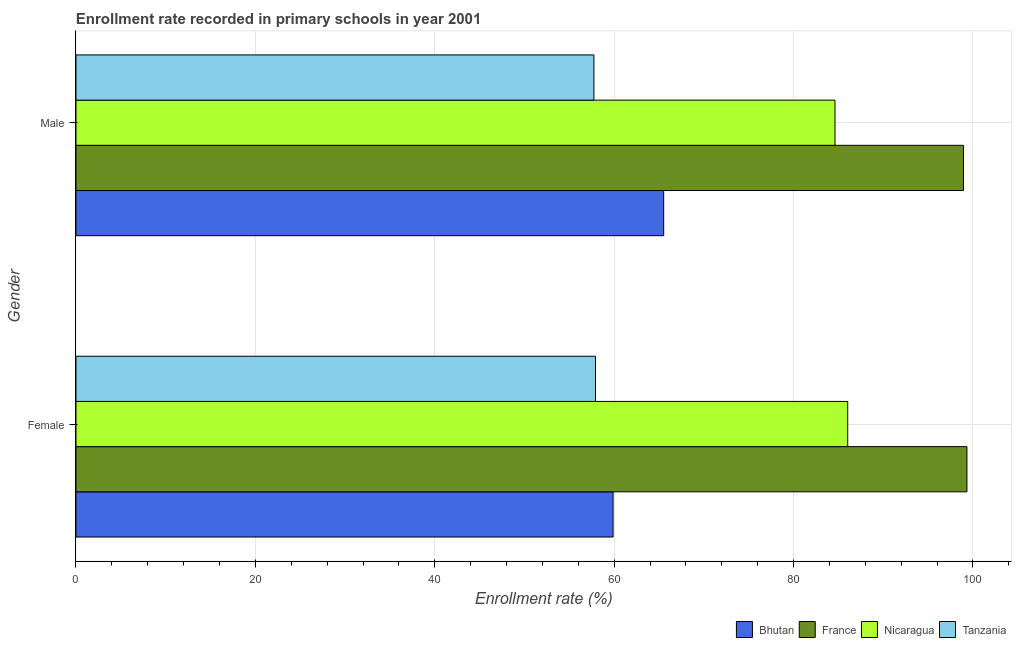How many different coloured bars are there?
Make the answer very short. 4. How many groups of bars are there?
Provide a succinct answer. 2. Are the number of bars per tick equal to the number of legend labels?
Keep it short and to the point. Yes. Are the number of bars on each tick of the Y-axis equal?
Make the answer very short. Yes. What is the label of the 1st group of bars from the top?
Keep it short and to the point. Male. What is the enrollment rate of male students in Nicaragua?
Provide a succinct answer. 84.62. Across all countries, what is the maximum enrollment rate of male students?
Give a very brief answer. 98.94. Across all countries, what is the minimum enrollment rate of male students?
Provide a succinct answer. 57.74. In which country was the enrollment rate of female students minimum?
Make the answer very short. Tanzania. What is the total enrollment rate of male students in the graph?
Your response must be concise. 306.82. What is the difference between the enrollment rate of female students in France and that in Tanzania?
Offer a terse response. 41.41. What is the difference between the enrollment rate of male students in Bhutan and the enrollment rate of female students in Nicaragua?
Offer a terse response. -20.52. What is the average enrollment rate of female students per country?
Keep it short and to the point. 75.79. What is the difference between the enrollment rate of male students and enrollment rate of female students in Nicaragua?
Keep it short and to the point. -1.42. In how many countries, is the enrollment rate of male students greater than 56 %?
Ensure brevity in your answer.  4. What is the ratio of the enrollment rate of male students in Nicaragua to that in Bhutan?
Make the answer very short. 1.29. In how many countries, is the enrollment rate of male students greater than the average enrollment rate of male students taken over all countries?
Offer a very short reply. 2. What does the 4th bar from the top in Male represents?
Make the answer very short. Bhutan. What does the 2nd bar from the bottom in Female represents?
Make the answer very short. France. How many bars are there?
Make the answer very short. 8. How many countries are there in the graph?
Your response must be concise. 4. What is the difference between two consecutive major ticks on the X-axis?
Offer a terse response. 20. Are the values on the major ticks of X-axis written in scientific E-notation?
Your answer should be very brief. No. How many legend labels are there?
Give a very brief answer. 4. What is the title of the graph?
Offer a terse response. Enrollment rate recorded in primary schools in year 2001. Does "Korea (Republic)" appear as one of the legend labels in the graph?
Offer a terse response. No. What is the label or title of the X-axis?
Offer a very short reply. Enrollment rate (%). What is the label or title of the Y-axis?
Your answer should be very brief. Gender. What is the Enrollment rate (%) in Bhutan in Female?
Provide a short and direct response. 59.88. What is the Enrollment rate (%) in France in Female?
Your answer should be very brief. 99.33. What is the Enrollment rate (%) in Nicaragua in Female?
Provide a short and direct response. 86.04. What is the Enrollment rate (%) of Tanzania in Female?
Your response must be concise. 57.92. What is the Enrollment rate (%) in Bhutan in Male?
Your answer should be compact. 65.52. What is the Enrollment rate (%) of France in Male?
Provide a succinct answer. 98.94. What is the Enrollment rate (%) in Nicaragua in Male?
Offer a very short reply. 84.62. What is the Enrollment rate (%) of Tanzania in Male?
Offer a very short reply. 57.74. Across all Gender, what is the maximum Enrollment rate (%) of Bhutan?
Provide a succinct answer. 65.52. Across all Gender, what is the maximum Enrollment rate (%) in France?
Offer a terse response. 99.33. Across all Gender, what is the maximum Enrollment rate (%) in Nicaragua?
Your answer should be very brief. 86.04. Across all Gender, what is the maximum Enrollment rate (%) in Tanzania?
Offer a very short reply. 57.92. Across all Gender, what is the minimum Enrollment rate (%) in Bhutan?
Give a very brief answer. 59.88. Across all Gender, what is the minimum Enrollment rate (%) of France?
Provide a succinct answer. 98.94. Across all Gender, what is the minimum Enrollment rate (%) of Nicaragua?
Ensure brevity in your answer.  84.62. Across all Gender, what is the minimum Enrollment rate (%) of Tanzania?
Provide a succinct answer. 57.74. What is the total Enrollment rate (%) in Bhutan in the graph?
Offer a very short reply. 125.4. What is the total Enrollment rate (%) in France in the graph?
Ensure brevity in your answer.  198.27. What is the total Enrollment rate (%) in Nicaragua in the graph?
Make the answer very short. 170.66. What is the total Enrollment rate (%) of Tanzania in the graph?
Your answer should be compact. 115.66. What is the difference between the Enrollment rate (%) in Bhutan in Female and that in Male?
Ensure brevity in your answer.  -5.64. What is the difference between the Enrollment rate (%) in France in Female and that in Male?
Ensure brevity in your answer.  0.39. What is the difference between the Enrollment rate (%) of Nicaragua in Female and that in Male?
Offer a very short reply. 1.42. What is the difference between the Enrollment rate (%) in Tanzania in Female and that in Male?
Make the answer very short. 0.17. What is the difference between the Enrollment rate (%) in Bhutan in Female and the Enrollment rate (%) in France in Male?
Offer a terse response. -39.06. What is the difference between the Enrollment rate (%) in Bhutan in Female and the Enrollment rate (%) in Nicaragua in Male?
Your answer should be very brief. -24.74. What is the difference between the Enrollment rate (%) of Bhutan in Female and the Enrollment rate (%) of Tanzania in Male?
Your answer should be very brief. 2.14. What is the difference between the Enrollment rate (%) of France in Female and the Enrollment rate (%) of Nicaragua in Male?
Offer a very short reply. 14.71. What is the difference between the Enrollment rate (%) in France in Female and the Enrollment rate (%) in Tanzania in Male?
Keep it short and to the point. 41.59. What is the difference between the Enrollment rate (%) in Nicaragua in Female and the Enrollment rate (%) in Tanzania in Male?
Offer a very short reply. 28.3. What is the average Enrollment rate (%) of Bhutan per Gender?
Keep it short and to the point. 62.7. What is the average Enrollment rate (%) in France per Gender?
Provide a short and direct response. 99.13. What is the average Enrollment rate (%) of Nicaragua per Gender?
Your answer should be compact. 85.33. What is the average Enrollment rate (%) in Tanzania per Gender?
Make the answer very short. 57.83. What is the difference between the Enrollment rate (%) of Bhutan and Enrollment rate (%) of France in Female?
Provide a short and direct response. -39.45. What is the difference between the Enrollment rate (%) of Bhutan and Enrollment rate (%) of Nicaragua in Female?
Your response must be concise. -26.16. What is the difference between the Enrollment rate (%) in Bhutan and Enrollment rate (%) in Tanzania in Female?
Provide a short and direct response. 1.96. What is the difference between the Enrollment rate (%) in France and Enrollment rate (%) in Nicaragua in Female?
Give a very brief answer. 13.29. What is the difference between the Enrollment rate (%) in France and Enrollment rate (%) in Tanzania in Female?
Your answer should be compact. 41.41. What is the difference between the Enrollment rate (%) in Nicaragua and Enrollment rate (%) in Tanzania in Female?
Offer a terse response. 28.12. What is the difference between the Enrollment rate (%) in Bhutan and Enrollment rate (%) in France in Male?
Offer a very short reply. -33.42. What is the difference between the Enrollment rate (%) of Bhutan and Enrollment rate (%) of Nicaragua in Male?
Your answer should be very brief. -19.1. What is the difference between the Enrollment rate (%) in Bhutan and Enrollment rate (%) in Tanzania in Male?
Your response must be concise. 7.78. What is the difference between the Enrollment rate (%) in France and Enrollment rate (%) in Nicaragua in Male?
Ensure brevity in your answer.  14.32. What is the difference between the Enrollment rate (%) of France and Enrollment rate (%) of Tanzania in Male?
Your answer should be compact. 41.2. What is the difference between the Enrollment rate (%) of Nicaragua and Enrollment rate (%) of Tanzania in Male?
Make the answer very short. 26.88. What is the ratio of the Enrollment rate (%) in Bhutan in Female to that in Male?
Keep it short and to the point. 0.91. What is the ratio of the Enrollment rate (%) in France in Female to that in Male?
Provide a succinct answer. 1. What is the ratio of the Enrollment rate (%) in Nicaragua in Female to that in Male?
Your answer should be very brief. 1.02. What is the difference between the highest and the second highest Enrollment rate (%) in Bhutan?
Offer a terse response. 5.64. What is the difference between the highest and the second highest Enrollment rate (%) in France?
Provide a short and direct response. 0.39. What is the difference between the highest and the second highest Enrollment rate (%) in Nicaragua?
Your answer should be very brief. 1.42. What is the difference between the highest and the second highest Enrollment rate (%) of Tanzania?
Your response must be concise. 0.17. What is the difference between the highest and the lowest Enrollment rate (%) of Bhutan?
Offer a very short reply. 5.64. What is the difference between the highest and the lowest Enrollment rate (%) in France?
Give a very brief answer. 0.39. What is the difference between the highest and the lowest Enrollment rate (%) in Nicaragua?
Your response must be concise. 1.42. What is the difference between the highest and the lowest Enrollment rate (%) of Tanzania?
Your answer should be compact. 0.17. 